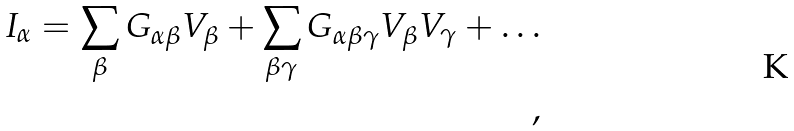<formula> <loc_0><loc_0><loc_500><loc_500>I _ { \alpha } = \sum _ { \beta } G _ { \alpha \beta } V _ { \beta } + \sum _ { \beta \gamma } G _ { \alpha \beta \gamma } V _ { \beta } V _ { \gamma } + \dots \\ ,</formula> 